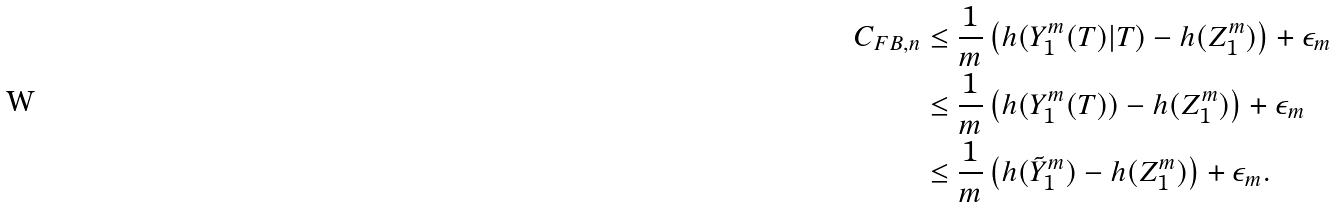<formula> <loc_0><loc_0><loc_500><loc_500>C _ { F B , n } & \leq \frac { 1 } { m } \left ( h ( Y _ { 1 } ^ { m } ( T ) | T ) - h ( Z _ { 1 } ^ { m } ) \right ) + \epsilon _ { m } \\ & \leq \frac { 1 } { m } \left ( h ( Y _ { 1 } ^ { m } ( T ) ) - h ( Z _ { 1 } ^ { m } ) \right ) + \epsilon _ { m } \\ & \leq \frac { 1 } { m } \left ( h ( \tilde { Y } _ { 1 } ^ { m } ) - h ( { Z } _ { 1 } ^ { m } ) \right ) + \epsilon _ { m } .</formula> 